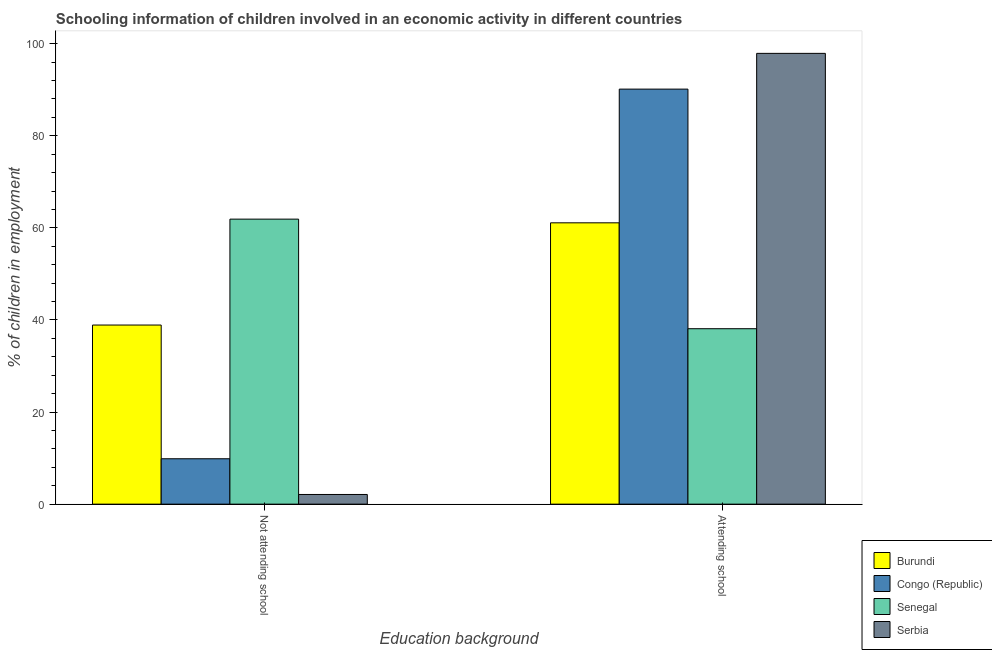How many different coloured bars are there?
Offer a terse response. 4. How many bars are there on the 2nd tick from the left?
Offer a very short reply. 4. How many bars are there on the 1st tick from the right?
Provide a succinct answer. 4. What is the label of the 2nd group of bars from the left?
Provide a short and direct response. Attending school. What is the percentage of employed children who are not attending school in Burundi?
Your answer should be very brief. 38.9. Across all countries, what is the maximum percentage of employed children who are attending school?
Make the answer very short. 97.9. Across all countries, what is the minimum percentage of employed children who are not attending school?
Offer a very short reply. 2.1. In which country was the percentage of employed children who are attending school maximum?
Provide a short and direct response. Serbia. In which country was the percentage of employed children who are not attending school minimum?
Provide a succinct answer. Serbia. What is the total percentage of employed children who are attending school in the graph?
Keep it short and to the point. 287.24. What is the difference between the percentage of employed children who are attending school in Serbia and that in Congo (Republic)?
Your response must be concise. 7.77. What is the difference between the percentage of employed children who are attending school in Serbia and the percentage of employed children who are not attending school in Senegal?
Offer a very short reply. 36. What is the average percentage of employed children who are not attending school per country?
Offer a very short reply. 28.19. What is the difference between the percentage of employed children who are attending school and percentage of employed children who are not attending school in Senegal?
Make the answer very short. -23.8. In how many countries, is the percentage of employed children who are attending school greater than 36 %?
Your answer should be very brief. 4. What is the ratio of the percentage of employed children who are attending school in Burundi to that in Senegal?
Keep it short and to the point. 1.6. Is the percentage of employed children who are attending school in Congo (Republic) less than that in Senegal?
Offer a very short reply. No. In how many countries, is the percentage of employed children who are not attending school greater than the average percentage of employed children who are not attending school taken over all countries?
Your response must be concise. 2. What does the 1st bar from the left in Not attending school represents?
Keep it short and to the point. Burundi. What does the 2nd bar from the right in Not attending school represents?
Your response must be concise. Senegal. How many bars are there?
Your answer should be compact. 8. Are all the bars in the graph horizontal?
Make the answer very short. No. What is the difference between two consecutive major ticks on the Y-axis?
Ensure brevity in your answer.  20. Does the graph contain any zero values?
Ensure brevity in your answer.  No. Where does the legend appear in the graph?
Provide a short and direct response. Bottom right. How many legend labels are there?
Your answer should be very brief. 4. What is the title of the graph?
Your answer should be very brief. Schooling information of children involved in an economic activity in different countries. What is the label or title of the X-axis?
Offer a very short reply. Education background. What is the label or title of the Y-axis?
Offer a very short reply. % of children in employment. What is the % of children in employment of Burundi in Not attending school?
Your response must be concise. 38.9. What is the % of children in employment of Congo (Republic) in Not attending school?
Make the answer very short. 9.86. What is the % of children in employment of Senegal in Not attending school?
Offer a terse response. 61.9. What is the % of children in employment of Burundi in Attending school?
Keep it short and to the point. 61.1. What is the % of children in employment in Congo (Republic) in Attending school?
Ensure brevity in your answer.  90.14. What is the % of children in employment of Senegal in Attending school?
Offer a very short reply. 38.1. What is the % of children in employment in Serbia in Attending school?
Offer a very short reply. 97.9. Across all Education background, what is the maximum % of children in employment in Burundi?
Your answer should be very brief. 61.1. Across all Education background, what is the maximum % of children in employment in Congo (Republic)?
Your response must be concise. 90.14. Across all Education background, what is the maximum % of children in employment of Senegal?
Your answer should be compact. 61.9. Across all Education background, what is the maximum % of children in employment in Serbia?
Give a very brief answer. 97.9. Across all Education background, what is the minimum % of children in employment in Burundi?
Your answer should be compact. 38.9. Across all Education background, what is the minimum % of children in employment of Congo (Republic)?
Offer a terse response. 9.86. Across all Education background, what is the minimum % of children in employment of Senegal?
Give a very brief answer. 38.1. Across all Education background, what is the minimum % of children in employment in Serbia?
Keep it short and to the point. 2.1. What is the total % of children in employment of Congo (Republic) in the graph?
Keep it short and to the point. 100. What is the total % of children in employment of Senegal in the graph?
Ensure brevity in your answer.  100. What is the difference between the % of children in employment of Burundi in Not attending school and that in Attending school?
Offer a very short reply. -22.2. What is the difference between the % of children in employment of Congo (Republic) in Not attending school and that in Attending school?
Provide a short and direct response. -80.28. What is the difference between the % of children in employment in Senegal in Not attending school and that in Attending school?
Offer a very short reply. 23.8. What is the difference between the % of children in employment in Serbia in Not attending school and that in Attending school?
Keep it short and to the point. -95.8. What is the difference between the % of children in employment of Burundi in Not attending school and the % of children in employment of Congo (Republic) in Attending school?
Your response must be concise. -51.23. What is the difference between the % of children in employment in Burundi in Not attending school and the % of children in employment in Serbia in Attending school?
Keep it short and to the point. -59. What is the difference between the % of children in employment of Congo (Republic) in Not attending school and the % of children in employment of Senegal in Attending school?
Make the answer very short. -28.24. What is the difference between the % of children in employment in Congo (Republic) in Not attending school and the % of children in employment in Serbia in Attending school?
Offer a very short reply. -88.04. What is the difference between the % of children in employment of Senegal in Not attending school and the % of children in employment of Serbia in Attending school?
Offer a very short reply. -36. What is the average % of children in employment of Congo (Republic) per Education background?
Provide a succinct answer. 50. What is the difference between the % of children in employment in Burundi and % of children in employment in Congo (Republic) in Not attending school?
Offer a terse response. 29.04. What is the difference between the % of children in employment of Burundi and % of children in employment of Senegal in Not attending school?
Keep it short and to the point. -23. What is the difference between the % of children in employment in Burundi and % of children in employment in Serbia in Not attending school?
Your response must be concise. 36.8. What is the difference between the % of children in employment in Congo (Republic) and % of children in employment in Senegal in Not attending school?
Ensure brevity in your answer.  -52.04. What is the difference between the % of children in employment of Congo (Republic) and % of children in employment of Serbia in Not attending school?
Make the answer very short. 7.76. What is the difference between the % of children in employment in Senegal and % of children in employment in Serbia in Not attending school?
Your response must be concise. 59.8. What is the difference between the % of children in employment of Burundi and % of children in employment of Congo (Republic) in Attending school?
Your answer should be compact. -29.04. What is the difference between the % of children in employment in Burundi and % of children in employment in Serbia in Attending school?
Make the answer very short. -36.8. What is the difference between the % of children in employment in Congo (Republic) and % of children in employment in Senegal in Attending school?
Offer a very short reply. 52.03. What is the difference between the % of children in employment of Congo (Republic) and % of children in employment of Serbia in Attending school?
Provide a succinct answer. -7.76. What is the difference between the % of children in employment in Senegal and % of children in employment in Serbia in Attending school?
Your response must be concise. -59.8. What is the ratio of the % of children in employment of Burundi in Not attending school to that in Attending school?
Your response must be concise. 0.64. What is the ratio of the % of children in employment in Congo (Republic) in Not attending school to that in Attending school?
Give a very brief answer. 0.11. What is the ratio of the % of children in employment in Senegal in Not attending school to that in Attending school?
Ensure brevity in your answer.  1.62. What is the ratio of the % of children in employment in Serbia in Not attending school to that in Attending school?
Your answer should be very brief. 0.02. What is the difference between the highest and the second highest % of children in employment in Congo (Republic)?
Ensure brevity in your answer.  80.28. What is the difference between the highest and the second highest % of children in employment in Senegal?
Offer a very short reply. 23.8. What is the difference between the highest and the second highest % of children in employment of Serbia?
Offer a terse response. 95.8. What is the difference between the highest and the lowest % of children in employment in Congo (Republic)?
Provide a succinct answer. 80.28. What is the difference between the highest and the lowest % of children in employment in Senegal?
Your answer should be very brief. 23.8. What is the difference between the highest and the lowest % of children in employment of Serbia?
Your response must be concise. 95.8. 